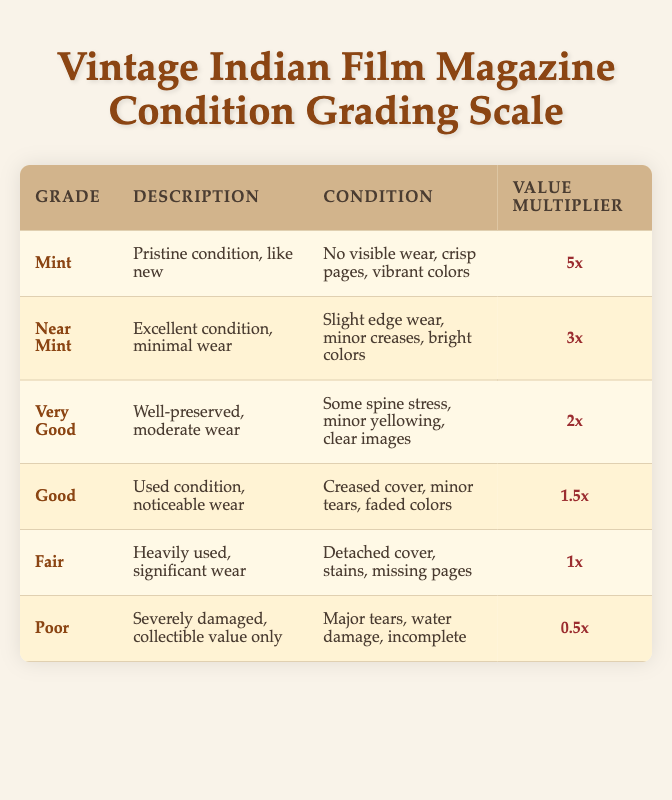What grade is assigned to the best condition? The best condition is represented by the "Mint" grade in the table.
Answer: Mint What is the value multiplier for a "Very Good" condition? The table indicates that the value multiplier for a "Very Good" condition is "2x."
Answer: 2x Is there any condition grade that has a value multiplier of 1x? Yes, the "Fair" condition grade has a value multiplier of 1x according to the table.
Answer: Yes Which grade has the description "Heavily used, significant wear"? The description "Heavily used, significant wear" corresponds to the "Fair" grade in the table.
Answer: Fair What is the difference in value multiplier between "Good" and "Poor" conditions? The value multiplier for "Good" is 1.5x, and for "Poor" it is 0.5x. The difference is calculated: 1.5x - 0.5x = 1.0x.
Answer: 1.0x How many grades have a value multiplier greater than 1x? The grades with a value multiplier greater than 1x are "Mint," "Near Mint," "Very Good," and "Good." This totals to four grades.
Answer: 4 What percentage of the total number of grades does the "Poor" grade represent? There are 6 total grades in the table. Since "Poor" is one of them, the percentage is calculated as (1/6) * 100 = 16.67%.
Answer: 16.67% Which condition grade has the most visible wear? The "Poor" condition grade clearly describes severe damage, indicating that it has the most visible wear among all grades.
Answer: Poor What grade has both "minor tears" and "faded colors"? The "Good" condition grade describes having "minor tears" and "faded colors," as outlined in the table.
Answer: Good 